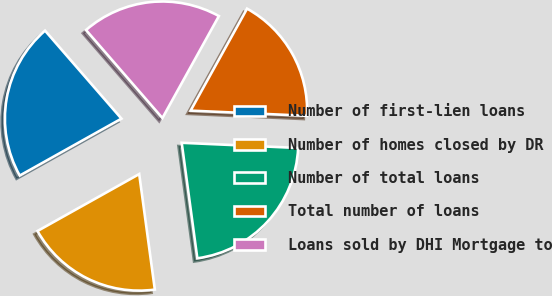Convert chart to OTSL. <chart><loc_0><loc_0><loc_500><loc_500><pie_chart><fcel>Number of first-lien loans<fcel>Number of homes closed by DR<fcel>Number of total loans<fcel>Total number of loans<fcel>Loans sold by DHI Mortgage to<nl><fcel>21.74%<fcel>19.02%<fcel>22.15%<fcel>17.66%<fcel>19.43%<nl></chart> 